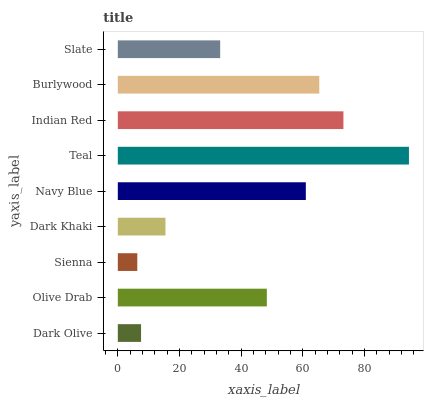Is Sienna the minimum?
Answer yes or no. Yes. Is Teal the maximum?
Answer yes or no. Yes. Is Olive Drab the minimum?
Answer yes or no. No. Is Olive Drab the maximum?
Answer yes or no. No. Is Olive Drab greater than Dark Olive?
Answer yes or no. Yes. Is Dark Olive less than Olive Drab?
Answer yes or no. Yes. Is Dark Olive greater than Olive Drab?
Answer yes or no. No. Is Olive Drab less than Dark Olive?
Answer yes or no. No. Is Olive Drab the high median?
Answer yes or no. Yes. Is Olive Drab the low median?
Answer yes or no. Yes. Is Navy Blue the high median?
Answer yes or no. No. Is Navy Blue the low median?
Answer yes or no. No. 